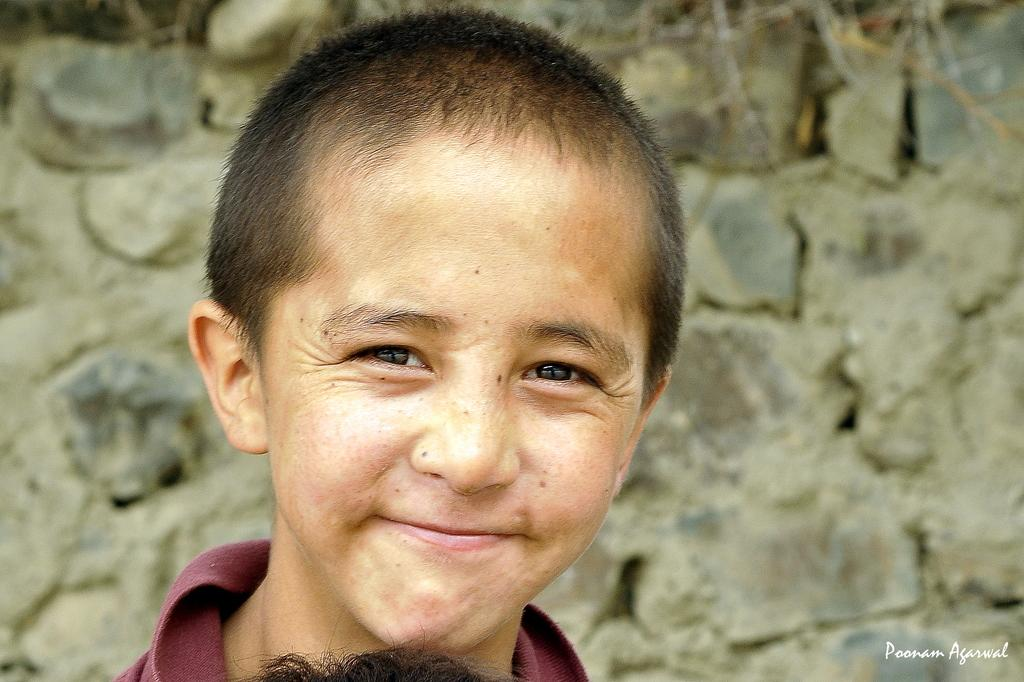What is the main subject of the image? There is a boy in the image. Can you describe the background of the boy? The background of the boy is blurred. What type of disease does the boy have in the image? There is no indication of any disease in the image; it only shows a boy with a blurred background. What does the boy's voice sound like in the image? The image is a still photograph and does not capture any sound, so it is not possible to determine the boy's voice. 